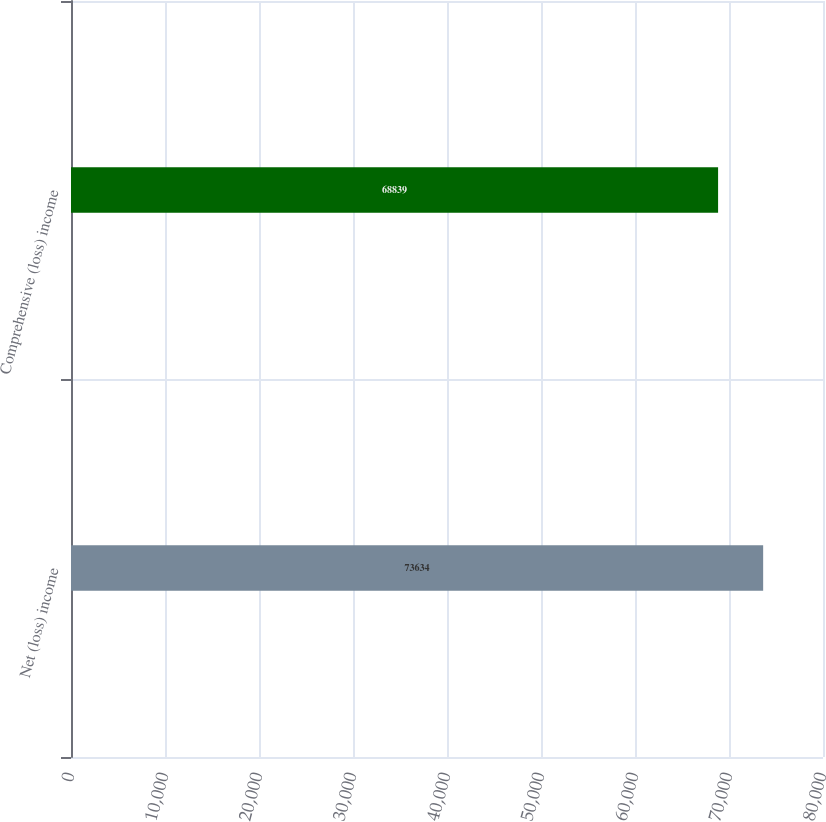Convert chart to OTSL. <chart><loc_0><loc_0><loc_500><loc_500><bar_chart><fcel>Net (loss) income<fcel>Comprehensive (loss) income<nl><fcel>73634<fcel>68839<nl></chart> 